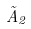<formula> <loc_0><loc_0><loc_500><loc_500>\tilde { A } _ { 2 }</formula> 